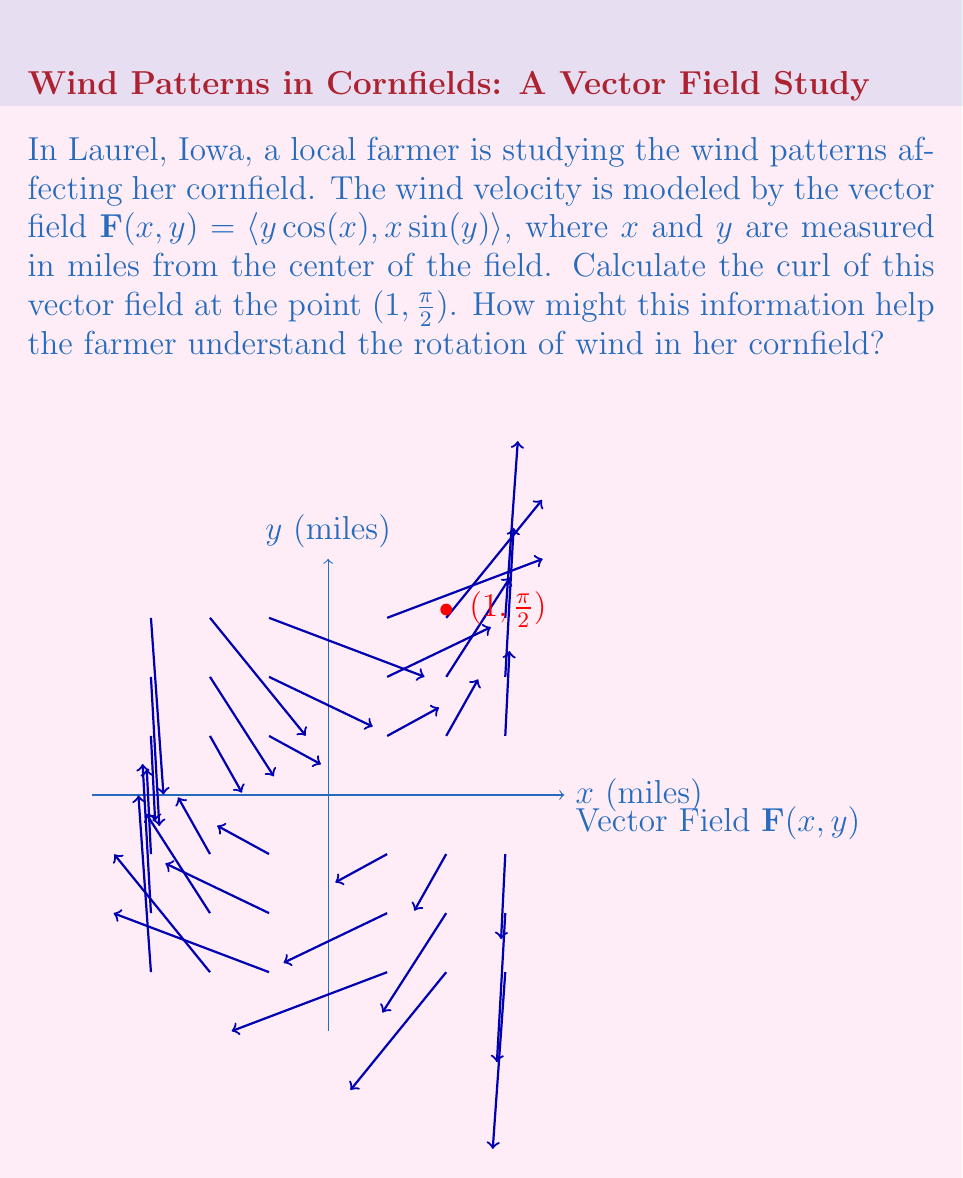Show me your answer to this math problem. To solve this problem, we'll follow these steps:

1) The curl of a 2D vector field $\mathbf{F}(x,y) = \langle P(x,y), Q(x,y) \rangle$ is given by:

   $\text{curl } \mathbf{F} = \frac{\partial Q}{\partial x} - \frac{\partial P}{\partial y}$

2) In our case, $P(x,y) = y\cos(x)$ and $Q(x,y) = x\sin(y)$

3) Let's calculate the partial derivatives:
   
   $\frac{\partial Q}{\partial x} = \sin(y)$
   
   $\frac{\partial P}{\partial y} = \cos(x)$

4) Now we can calculate the curl:

   $\text{curl } \mathbf{F} = \sin(y) - \cos(x)$

5) We need to evaluate this at the point $(1, \frac{\pi}{2})$:

   $\text{curl } \mathbf{F}(1, \frac{\pi}{2}) = \sin(\frac{\pi}{2}) - \cos(1)$

6) Simplify:
   
   $\text{curl } \mathbf{F}(1, \frac{\pi}{2}) = 1 - \cos(1) \approx 0.4596$

This positive curl indicates a counterclockwise rotation in the wind at this point. The farmer can use this information to understand how wind rotates around different parts of her field, which could affect pollination, moisture distribution, and the spread of airborne plant diseases in her corn crop.
Answer: $1 - \cos(1) \approx 0.4596$ 